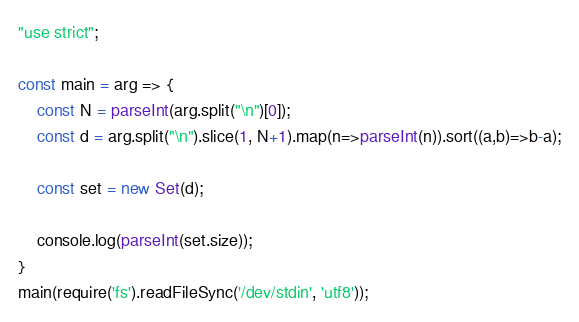Convert code to text. <code><loc_0><loc_0><loc_500><loc_500><_JavaScript_>"use strict";
    
const main = arg => {
    const N = parseInt(arg.split("\n")[0]);
    const d = arg.split("\n").slice(1, N+1).map(n=>parseInt(n)).sort((a,b)=>b-a);
    
    const set = new Set(d);
    
    console.log(parseInt(set.size));
}
main(require('fs').readFileSync('/dev/stdin', 'utf8'));
</code> 